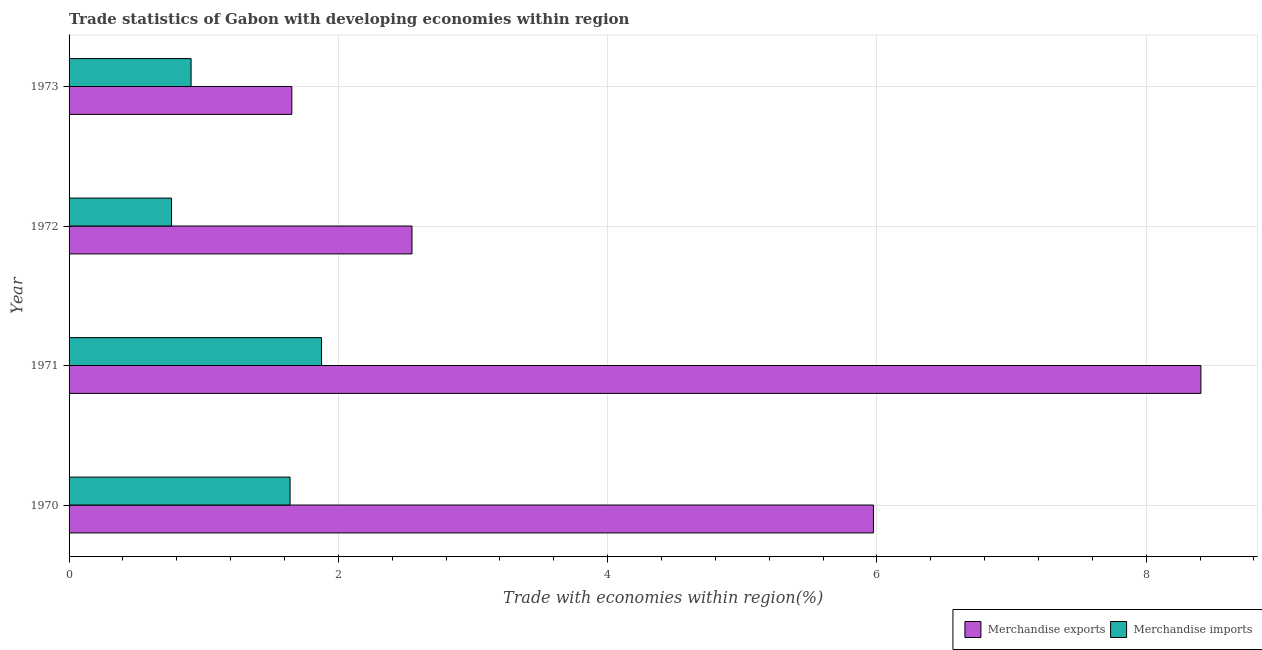How many different coloured bars are there?
Your answer should be compact. 2. How many groups of bars are there?
Keep it short and to the point. 4. How many bars are there on the 1st tick from the top?
Your answer should be very brief. 2. How many bars are there on the 4th tick from the bottom?
Give a very brief answer. 2. What is the label of the 2nd group of bars from the top?
Make the answer very short. 1972. What is the merchandise imports in 1970?
Offer a terse response. 1.64. Across all years, what is the maximum merchandise exports?
Give a very brief answer. 8.41. Across all years, what is the minimum merchandise imports?
Ensure brevity in your answer.  0.76. In which year was the merchandise exports minimum?
Ensure brevity in your answer.  1973. What is the total merchandise imports in the graph?
Provide a succinct answer. 5.18. What is the difference between the merchandise imports in 1971 and the merchandise exports in 1970?
Offer a very short reply. -4.1. What is the average merchandise imports per year?
Offer a terse response. 1.3. In the year 1971, what is the difference between the merchandise exports and merchandise imports?
Provide a succinct answer. 6.53. What is the ratio of the merchandise imports in 1972 to that in 1973?
Provide a short and direct response. 0.84. Is the merchandise imports in 1971 less than that in 1972?
Give a very brief answer. No. Is the difference between the merchandise imports in 1971 and 1973 greater than the difference between the merchandise exports in 1971 and 1973?
Your response must be concise. No. What is the difference between the highest and the second highest merchandise imports?
Provide a short and direct response. 0.23. What is the difference between the highest and the lowest merchandise exports?
Keep it short and to the point. 6.75. What does the 2nd bar from the bottom in 1970 represents?
Your response must be concise. Merchandise imports. Are all the bars in the graph horizontal?
Offer a terse response. Yes. Does the graph contain any zero values?
Keep it short and to the point. No. Does the graph contain grids?
Provide a short and direct response. Yes. What is the title of the graph?
Keep it short and to the point. Trade statistics of Gabon with developing economies within region. Does "Urban" appear as one of the legend labels in the graph?
Offer a very short reply. No. What is the label or title of the X-axis?
Provide a short and direct response. Trade with economies within region(%). What is the Trade with economies within region(%) of Merchandise exports in 1970?
Give a very brief answer. 5.97. What is the Trade with economies within region(%) of Merchandise imports in 1970?
Your answer should be very brief. 1.64. What is the Trade with economies within region(%) of Merchandise exports in 1971?
Keep it short and to the point. 8.41. What is the Trade with economies within region(%) in Merchandise imports in 1971?
Offer a terse response. 1.88. What is the Trade with economies within region(%) of Merchandise exports in 1972?
Provide a short and direct response. 2.55. What is the Trade with economies within region(%) of Merchandise imports in 1972?
Offer a terse response. 0.76. What is the Trade with economies within region(%) of Merchandise exports in 1973?
Offer a very short reply. 1.65. What is the Trade with economies within region(%) of Merchandise imports in 1973?
Provide a short and direct response. 0.91. Across all years, what is the maximum Trade with economies within region(%) in Merchandise exports?
Your response must be concise. 8.41. Across all years, what is the maximum Trade with economies within region(%) of Merchandise imports?
Ensure brevity in your answer.  1.88. Across all years, what is the minimum Trade with economies within region(%) of Merchandise exports?
Your response must be concise. 1.65. Across all years, what is the minimum Trade with economies within region(%) in Merchandise imports?
Your answer should be very brief. 0.76. What is the total Trade with economies within region(%) of Merchandise exports in the graph?
Keep it short and to the point. 18.58. What is the total Trade with economies within region(%) in Merchandise imports in the graph?
Offer a terse response. 5.18. What is the difference between the Trade with economies within region(%) in Merchandise exports in 1970 and that in 1971?
Give a very brief answer. -2.43. What is the difference between the Trade with economies within region(%) in Merchandise imports in 1970 and that in 1971?
Provide a short and direct response. -0.23. What is the difference between the Trade with economies within region(%) of Merchandise exports in 1970 and that in 1972?
Ensure brevity in your answer.  3.43. What is the difference between the Trade with economies within region(%) in Merchandise imports in 1970 and that in 1972?
Offer a very short reply. 0.88. What is the difference between the Trade with economies within region(%) in Merchandise exports in 1970 and that in 1973?
Provide a short and direct response. 4.32. What is the difference between the Trade with economies within region(%) in Merchandise imports in 1970 and that in 1973?
Your response must be concise. 0.74. What is the difference between the Trade with economies within region(%) in Merchandise exports in 1971 and that in 1972?
Keep it short and to the point. 5.86. What is the difference between the Trade with economies within region(%) of Merchandise imports in 1971 and that in 1972?
Your answer should be compact. 1.11. What is the difference between the Trade with economies within region(%) of Merchandise exports in 1971 and that in 1973?
Offer a very short reply. 6.75. What is the difference between the Trade with economies within region(%) of Merchandise imports in 1971 and that in 1973?
Your response must be concise. 0.97. What is the difference between the Trade with economies within region(%) in Merchandise exports in 1972 and that in 1973?
Offer a terse response. 0.89. What is the difference between the Trade with economies within region(%) in Merchandise imports in 1972 and that in 1973?
Your response must be concise. -0.15. What is the difference between the Trade with economies within region(%) of Merchandise exports in 1970 and the Trade with economies within region(%) of Merchandise imports in 1971?
Offer a terse response. 4.1. What is the difference between the Trade with economies within region(%) in Merchandise exports in 1970 and the Trade with economies within region(%) in Merchandise imports in 1972?
Ensure brevity in your answer.  5.21. What is the difference between the Trade with economies within region(%) of Merchandise exports in 1970 and the Trade with economies within region(%) of Merchandise imports in 1973?
Give a very brief answer. 5.07. What is the difference between the Trade with economies within region(%) of Merchandise exports in 1971 and the Trade with economies within region(%) of Merchandise imports in 1972?
Your answer should be very brief. 7.65. What is the difference between the Trade with economies within region(%) in Merchandise exports in 1971 and the Trade with economies within region(%) in Merchandise imports in 1973?
Offer a terse response. 7.5. What is the difference between the Trade with economies within region(%) of Merchandise exports in 1972 and the Trade with economies within region(%) of Merchandise imports in 1973?
Provide a succinct answer. 1.64. What is the average Trade with economies within region(%) in Merchandise exports per year?
Your response must be concise. 4.65. What is the average Trade with economies within region(%) of Merchandise imports per year?
Your answer should be compact. 1.3. In the year 1970, what is the difference between the Trade with economies within region(%) in Merchandise exports and Trade with economies within region(%) in Merchandise imports?
Provide a short and direct response. 4.33. In the year 1971, what is the difference between the Trade with economies within region(%) in Merchandise exports and Trade with economies within region(%) in Merchandise imports?
Offer a very short reply. 6.53. In the year 1972, what is the difference between the Trade with economies within region(%) in Merchandise exports and Trade with economies within region(%) in Merchandise imports?
Provide a succinct answer. 1.79. In the year 1973, what is the difference between the Trade with economies within region(%) of Merchandise exports and Trade with economies within region(%) of Merchandise imports?
Give a very brief answer. 0.75. What is the ratio of the Trade with economies within region(%) of Merchandise exports in 1970 to that in 1971?
Make the answer very short. 0.71. What is the ratio of the Trade with economies within region(%) of Merchandise imports in 1970 to that in 1971?
Provide a succinct answer. 0.88. What is the ratio of the Trade with economies within region(%) in Merchandise exports in 1970 to that in 1972?
Provide a succinct answer. 2.35. What is the ratio of the Trade with economies within region(%) in Merchandise imports in 1970 to that in 1972?
Ensure brevity in your answer.  2.16. What is the ratio of the Trade with economies within region(%) in Merchandise exports in 1970 to that in 1973?
Ensure brevity in your answer.  3.61. What is the ratio of the Trade with economies within region(%) of Merchandise imports in 1970 to that in 1973?
Offer a terse response. 1.81. What is the ratio of the Trade with economies within region(%) of Merchandise exports in 1971 to that in 1972?
Keep it short and to the point. 3.3. What is the ratio of the Trade with economies within region(%) in Merchandise imports in 1971 to that in 1972?
Your answer should be compact. 2.46. What is the ratio of the Trade with economies within region(%) in Merchandise exports in 1971 to that in 1973?
Give a very brief answer. 5.08. What is the ratio of the Trade with economies within region(%) of Merchandise imports in 1971 to that in 1973?
Give a very brief answer. 2.07. What is the ratio of the Trade with economies within region(%) of Merchandise exports in 1972 to that in 1973?
Ensure brevity in your answer.  1.54. What is the ratio of the Trade with economies within region(%) of Merchandise imports in 1972 to that in 1973?
Your answer should be compact. 0.84. What is the difference between the highest and the second highest Trade with economies within region(%) of Merchandise exports?
Your response must be concise. 2.43. What is the difference between the highest and the second highest Trade with economies within region(%) of Merchandise imports?
Make the answer very short. 0.23. What is the difference between the highest and the lowest Trade with economies within region(%) of Merchandise exports?
Make the answer very short. 6.75. What is the difference between the highest and the lowest Trade with economies within region(%) in Merchandise imports?
Your answer should be very brief. 1.11. 